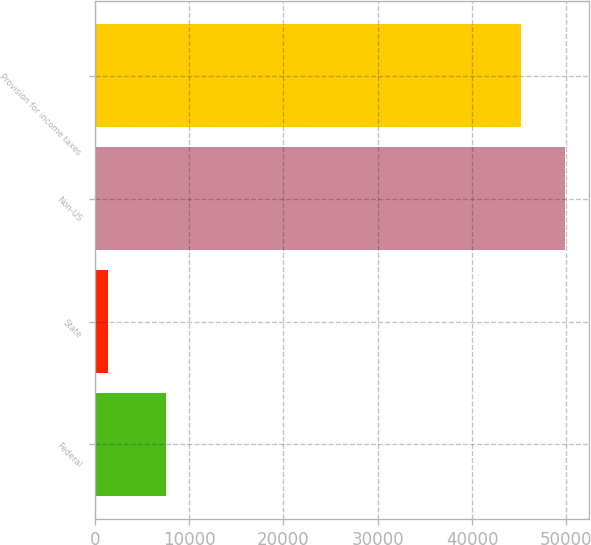Convert chart. <chart><loc_0><loc_0><loc_500><loc_500><bar_chart><fcel>Federal<fcel>State<fcel>Non-US<fcel>Provision for income taxes<nl><fcel>7507<fcel>1370<fcel>49868.1<fcel>45183<nl></chart> 